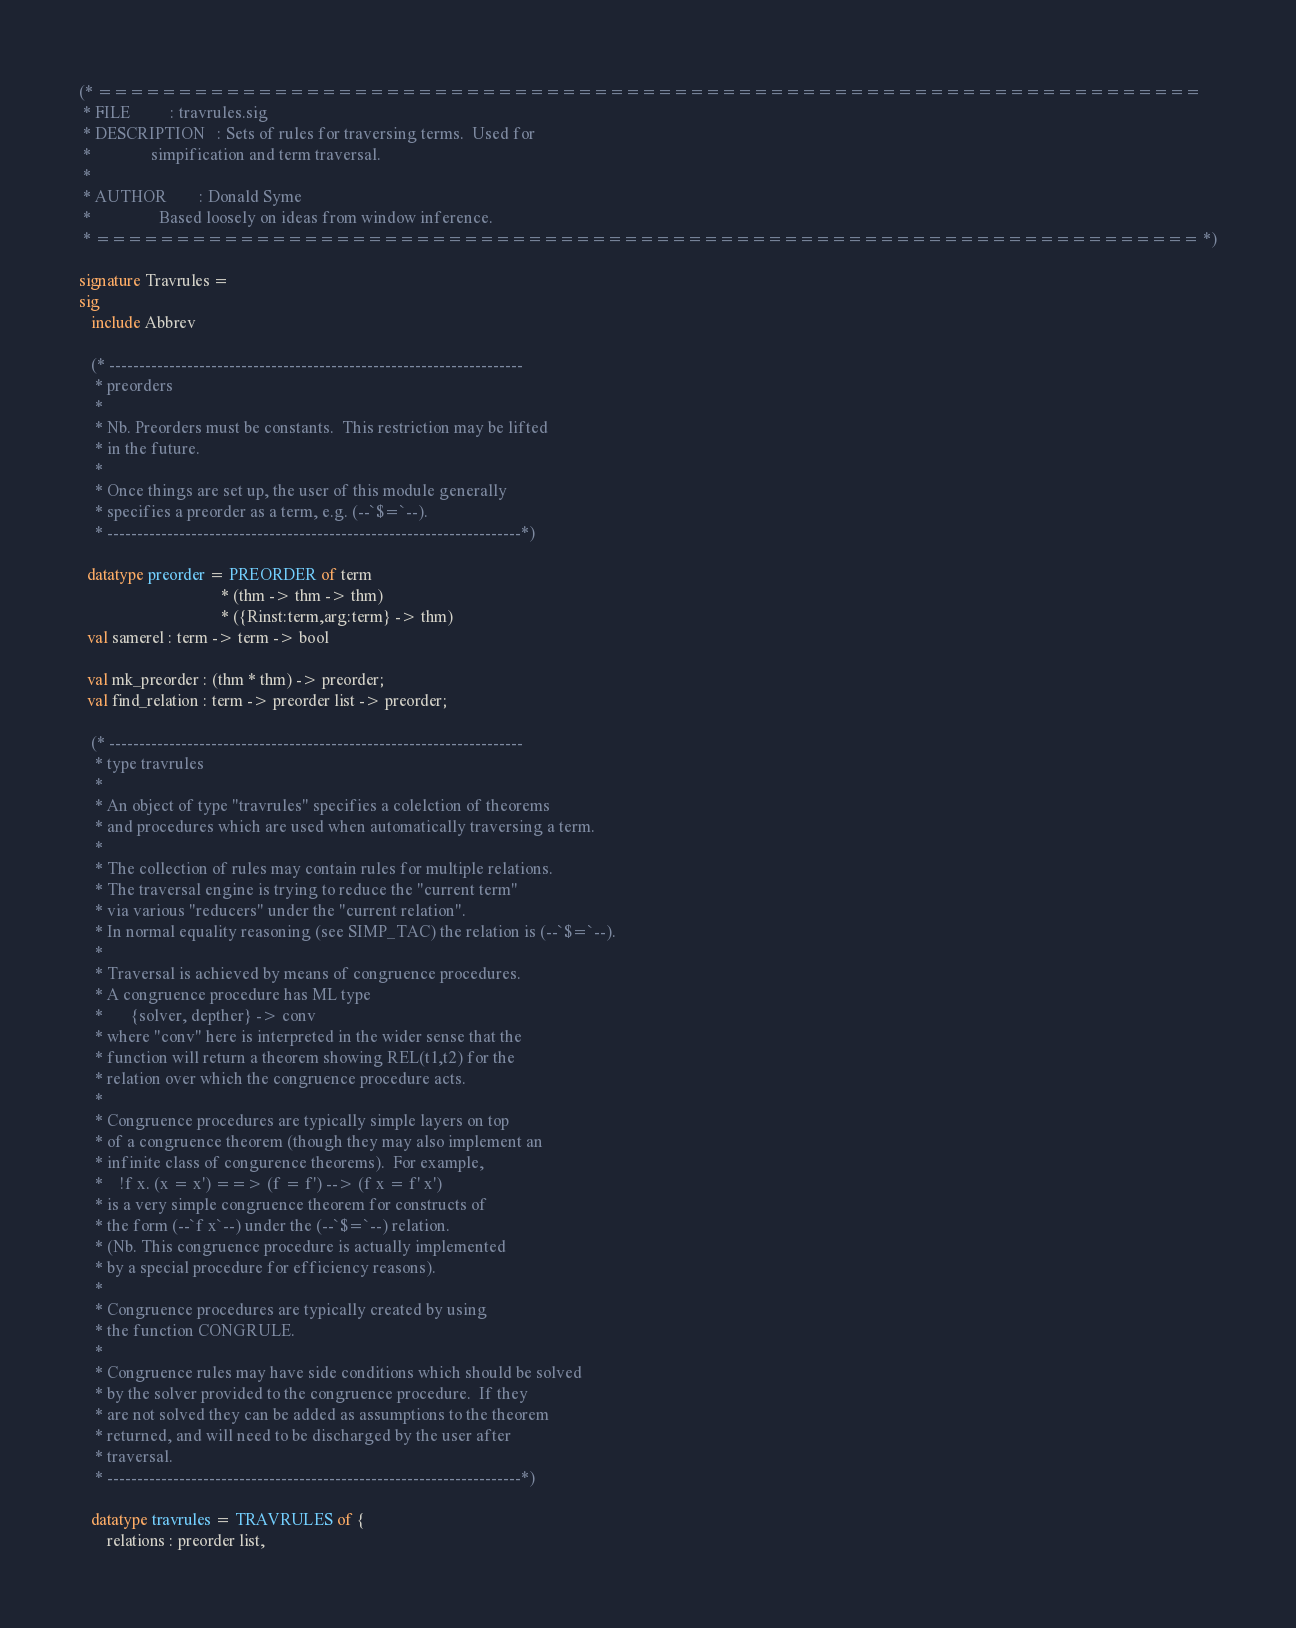<code> <loc_0><loc_0><loc_500><loc_500><_SML_>(* =====================================================================
 * FILE          : travrules.sig
 * DESCRIPTION   : Sets of rules for traversing terms.  Used for
 *	           simpification and term traversal.
 *
 * AUTHOR        : Donald Syme
 *                 Based loosely on ideas from window inference.
 * ===================================================================== *)

signature Travrules =
sig
   include Abbrev

   (* ---------------------------------------------------------------------
    * preorders
    *
    * Nb. Preorders must be constants.  This restriction may be lifted
    * in the future.
    *
    * Once things are set up, the user of this module generally
    * specifies a preorder as a term, e.g. (--`$=`--).
    * ---------------------------------------------------------------------*)

  datatype preorder = PREORDER of term
                                   * (thm -> thm -> thm)
                                   * ({Rinst:term,arg:term} -> thm)
  val samerel : term -> term -> bool

  val mk_preorder : (thm * thm) -> preorder;
  val find_relation : term -> preorder list -> preorder;

   (* ---------------------------------------------------------------------
    * type travrules
    *
    * An object of type "travrules" specifies a colelction of theorems
    * and procedures which are used when automatically traversing a term.
    *
    * The collection of rules may contain rules for multiple relations.
    * The traversal engine is trying to reduce the "current term"
    * via various "reducers" under the "current relation".
    * In normal equality reasoning (see SIMP_TAC) the relation is (--`$=`--).
    *
    * Traversal is achieved by means of congruence procedures.
    * A congruence procedure has ML type
    *       {solver, depther} -> conv
    * where "conv" here is interpreted in the wider sense that the
    * function will return a theorem showing REL(t1,t2) for the
    * relation over which the congruence procedure acts.
    *
    * Congruence procedures are typically simple layers on top
    * of a congruence theorem (though they may also implement an
    * infinite class of congurence theorems).  For example,
    *    !f x. (x = x') ==> (f = f') --> (f x = f' x')
    * is a very simple congruence theorem for constructs of
    * the form (--`f x`--) under the (--`$=`--) relation.
    * (Nb. This congruence procedure is actually implemented
    * by a special procedure for efficiency reasons).
    *
    * Congruence procedures are typically created by using
    * the function CONGRULE.
    *
    * Congruence rules may have side conditions which should be solved
    * by the solver provided to the congruence procedure.  If they
    * are not solved they can be added as assumptions to the theorem
    * returned, and will need to be discharged by the user after
    * traversal.
    * ---------------------------------------------------------------------*)

   datatype travrules = TRAVRULES of {
       relations : preorder list,</code> 